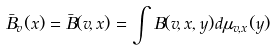<formula> <loc_0><loc_0><loc_500><loc_500>\bar { B } _ { v } ( x ) = \bar { B } ( v , x ) = \int B ( v , x , y ) d \mu _ { v , x } ( y )</formula> 